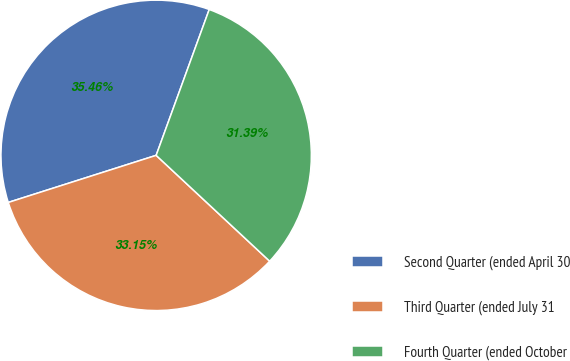Convert chart to OTSL. <chart><loc_0><loc_0><loc_500><loc_500><pie_chart><fcel>Second Quarter (ended April 30<fcel>Third Quarter (ended July 31<fcel>Fourth Quarter (ended October<nl><fcel>35.46%<fcel>33.15%<fcel>31.39%<nl></chart> 